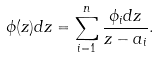<formula> <loc_0><loc_0><loc_500><loc_500>\phi ( z ) d z = \sum _ { i = 1 } ^ { n } \frac { \phi _ { i } d z } { z - a _ { i } } .</formula> 